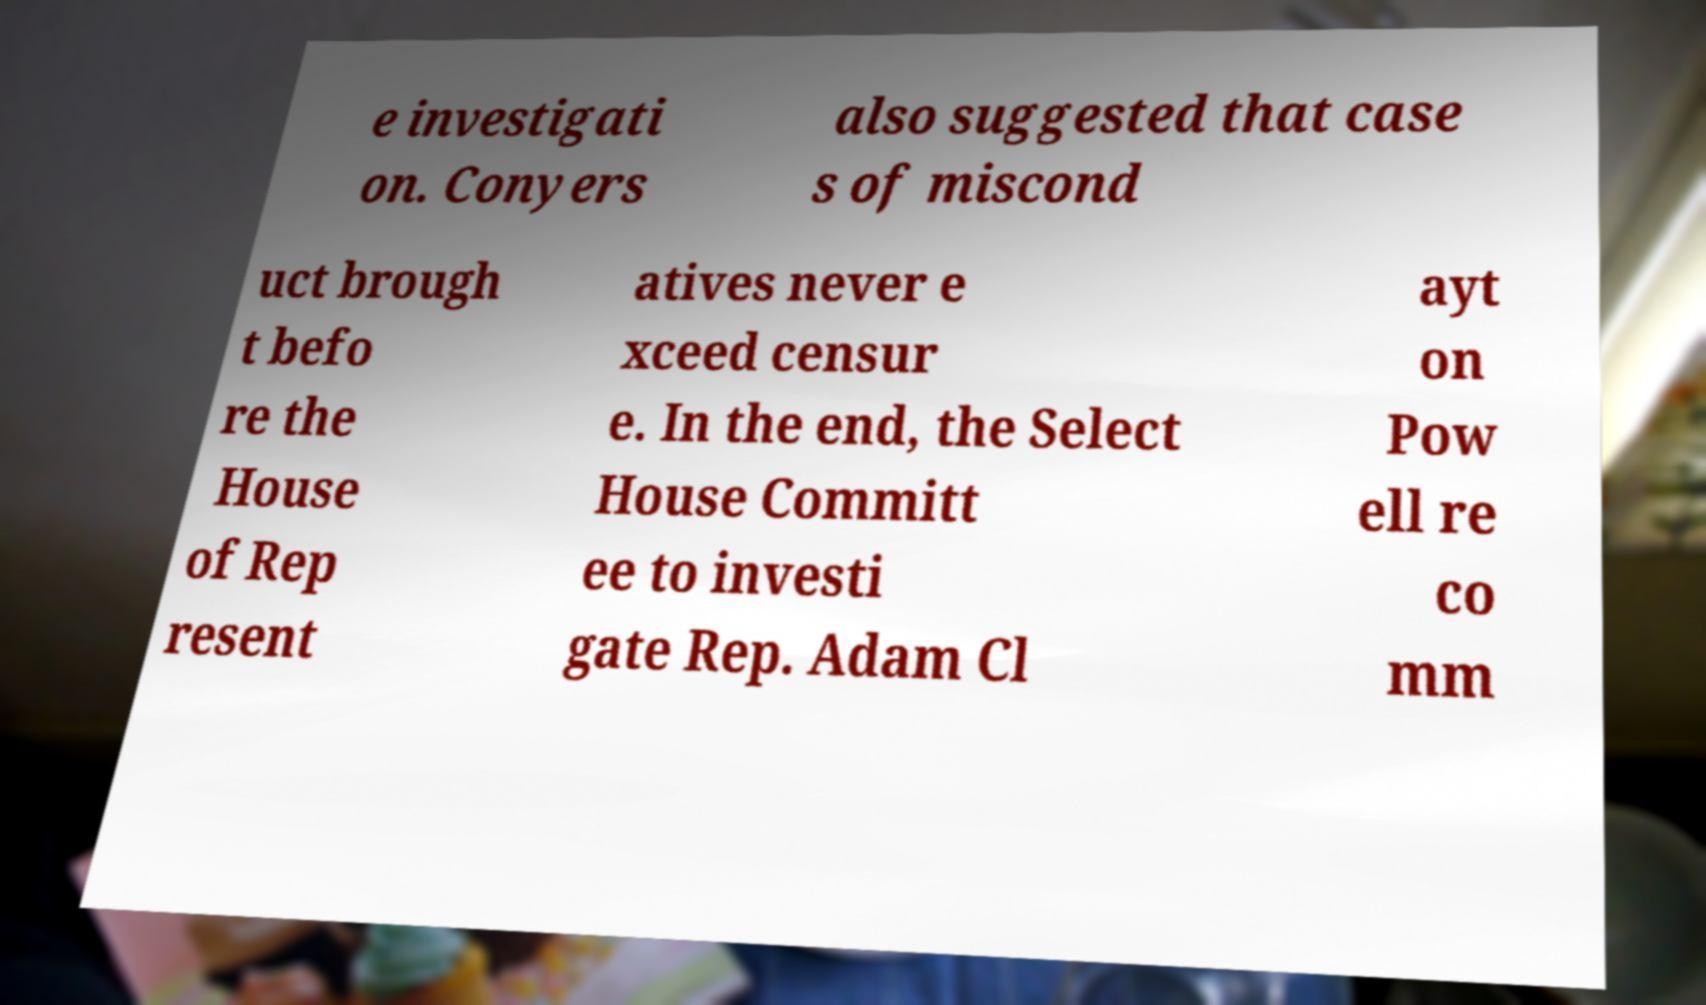There's text embedded in this image that I need extracted. Can you transcribe it verbatim? e investigati on. Conyers also suggested that case s of miscond uct brough t befo re the House of Rep resent atives never e xceed censur e. In the end, the Select House Committ ee to investi gate Rep. Adam Cl ayt on Pow ell re co mm 